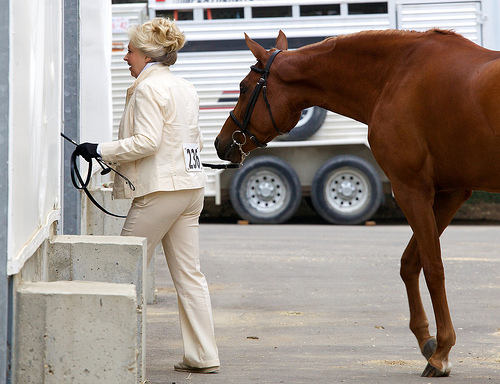<image>
Is the horse under the tire? No. The horse is not positioned under the tire. The vertical relationship between these objects is different. Is there a horse in front of the wheel? Yes. The horse is positioned in front of the wheel, appearing closer to the camera viewpoint. Where is the women in relation to the horse? Is it in front of the horse? Yes. The women is positioned in front of the horse, appearing closer to the camera viewpoint. 